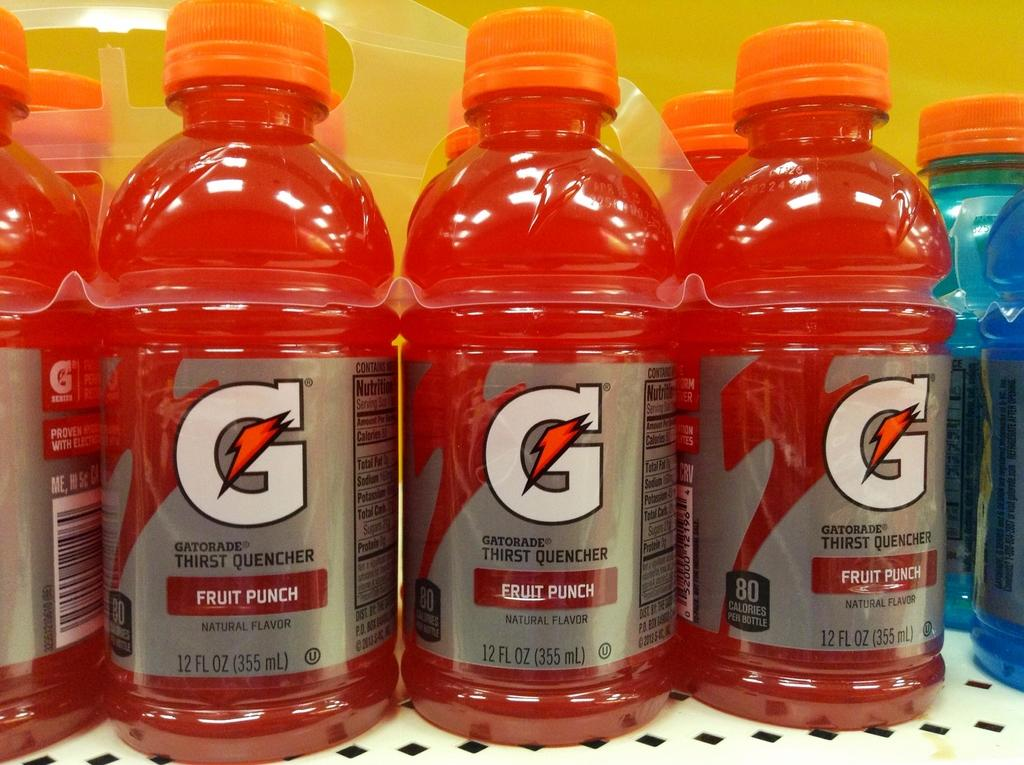<image>
Write a terse but informative summary of the picture. A multi-pack of Fruit Punch flavor Gatorade held by a thin plastic packaging. 